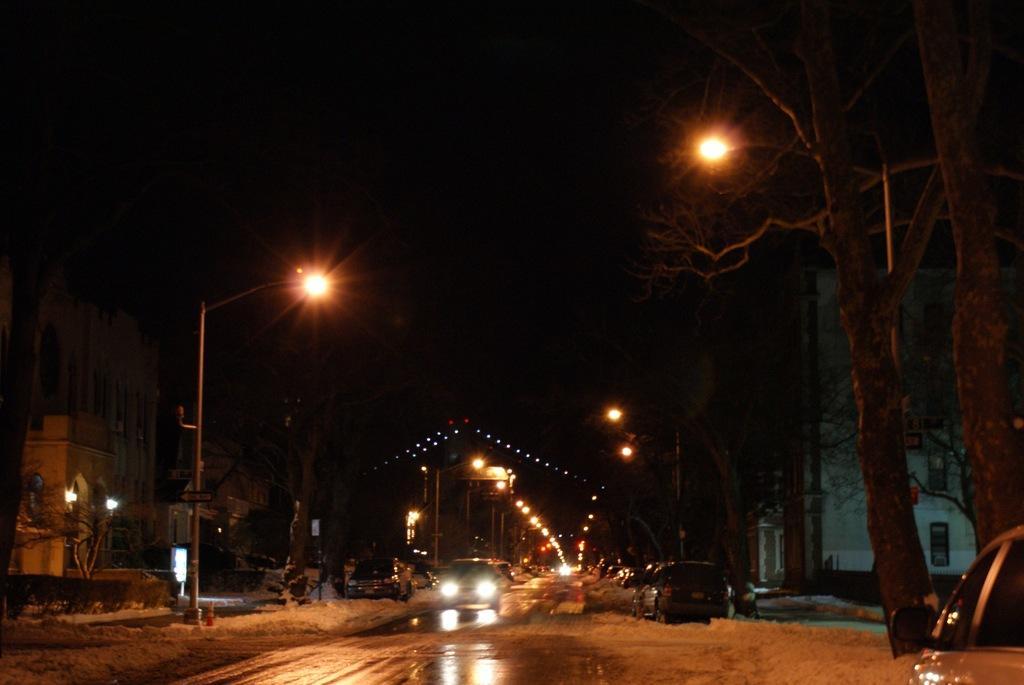Describe this image in one or two sentences. In this picture we can see many cars on the road. Beside the road we can see street lights. In the background we can see the building, trees, plants and grass. At the top we can see the darkness. 